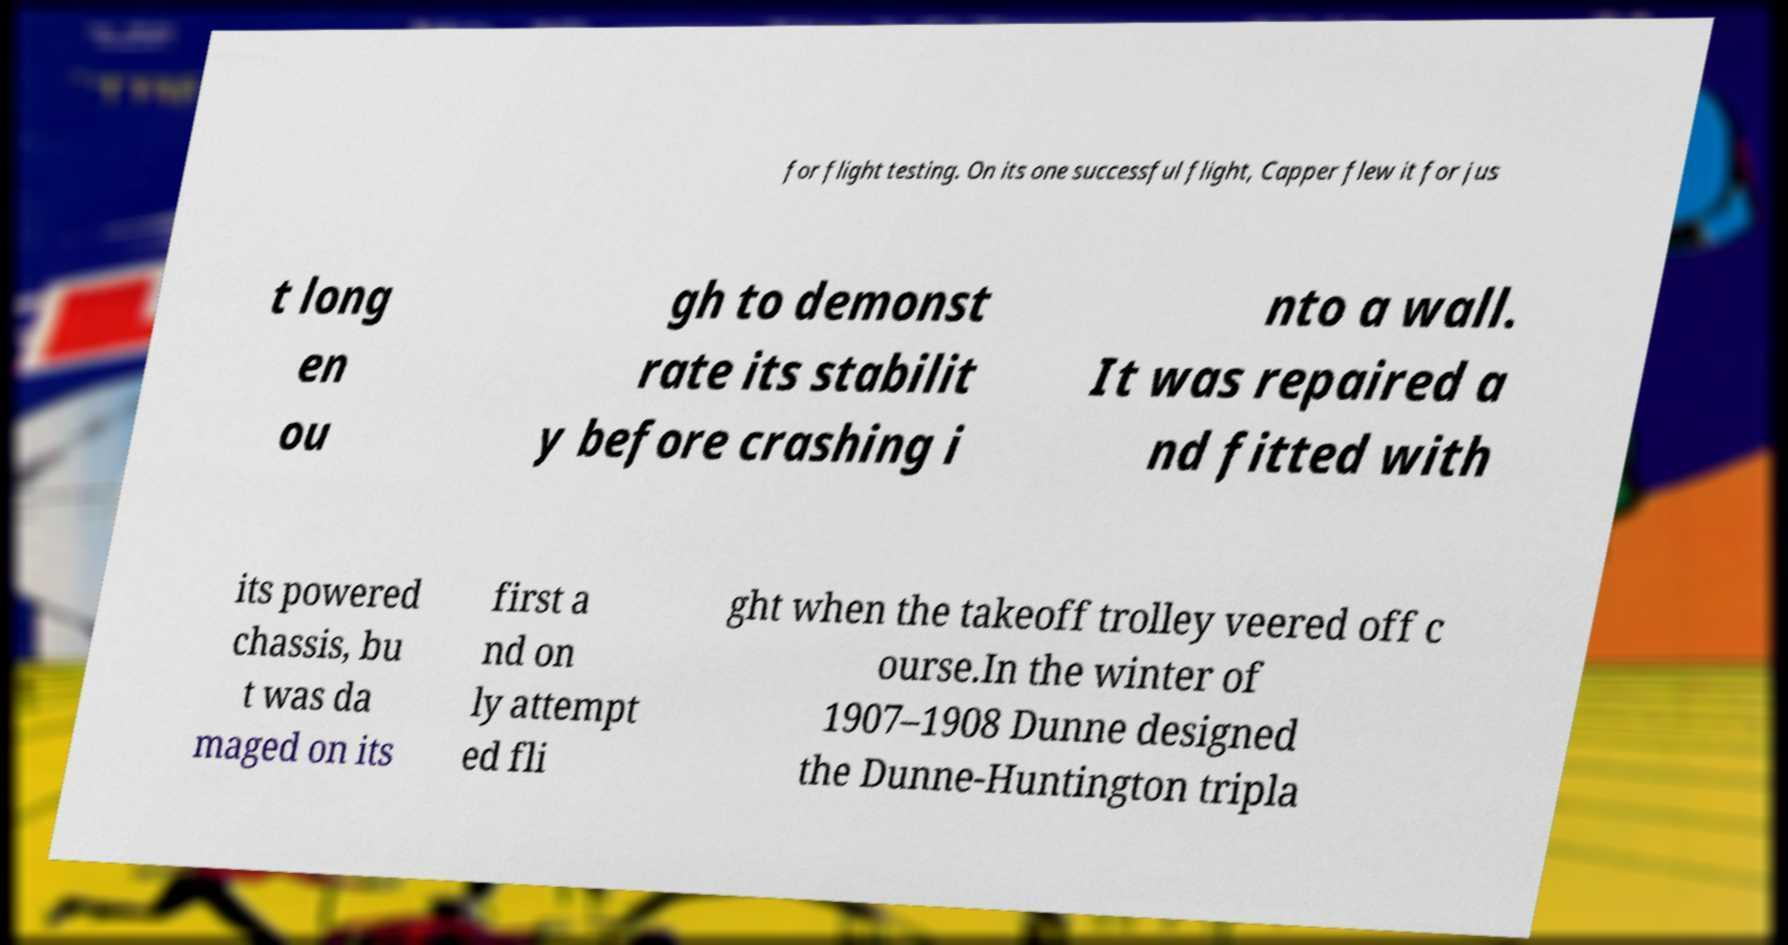For documentation purposes, I need the text within this image transcribed. Could you provide that? for flight testing. On its one successful flight, Capper flew it for jus t long en ou gh to demonst rate its stabilit y before crashing i nto a wall. It was repaired a nd fitted with its powered chassis, bu t was da maged on its first a nd on ly attempt ed fli ght when the takeoff trolley veered off c ourse.In the winter of 1907–1908 Dunne designed the Dunne-Huntington tripla 